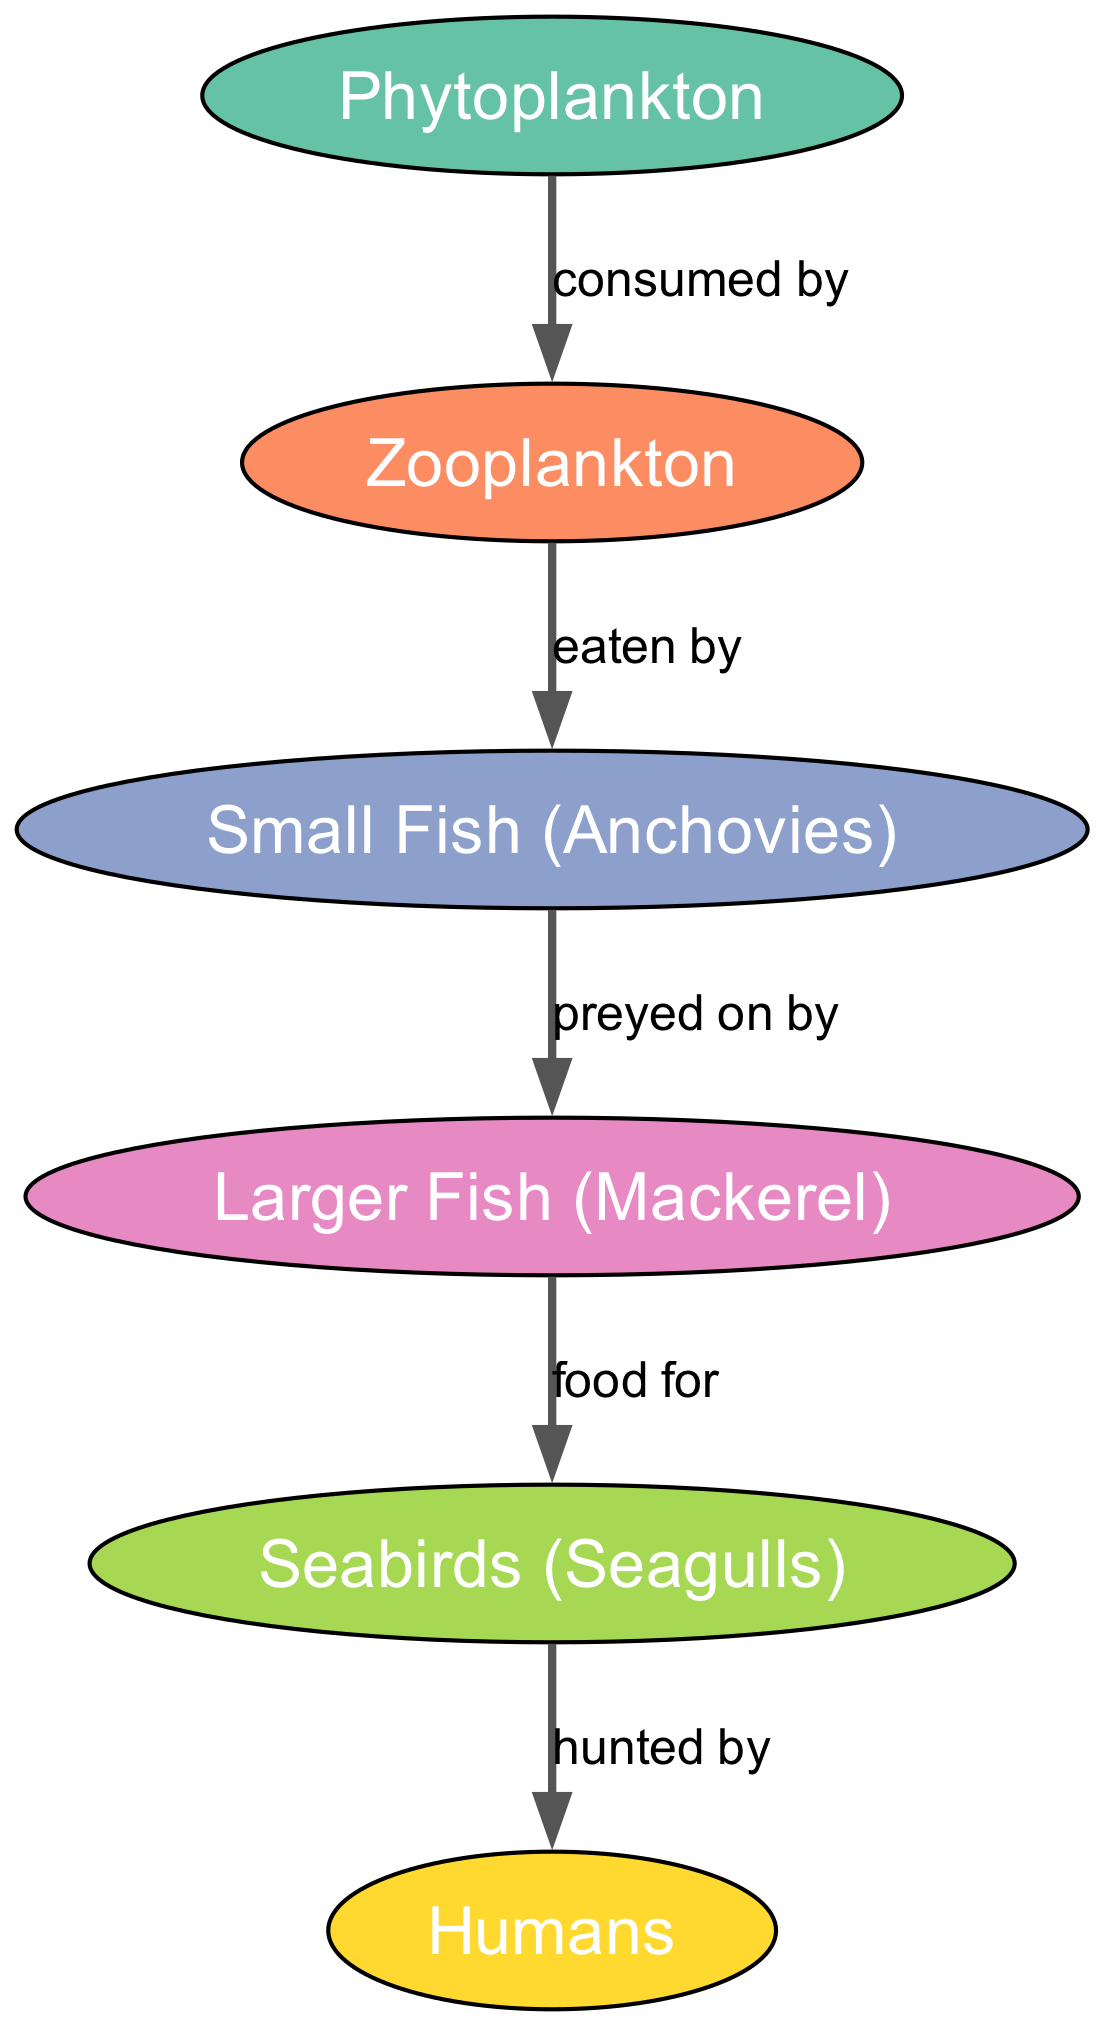What is the first node in the food chain? The first node in the food chain is Phytoplankton, as it is positioned at the top of the diagram and has edges leading to other nodes.
Answer: Phytoplankton How many edges are present in the diagram? The diagram shows a total of 5 edges connecting the nodes, indicating the relationships in the food chain.
Answer: 5 Which species is directly eaten by larger fish? According to the diagram, Small Fish (Anchovies) is the species that is directly eaten by Larger Fish (Mackerel), as indicated by the edge connecting them.
Answer: Small Fish (Anchovies) What type of relationship exists between seabirds and humans? The relationship between seabirds (Seagulls) and humans is labeled as "hunted by," which signifies that humans hunt seabirds as part of the food chain.
Answer: hunted by Which organism serves as a food source for seabirds? The diagram clearly indicates that Larger Fish (Mackerel) serves as a food source for Seabirds (Seagulls), shown by the directed edge leading from one to the other.
Answer: Larger Fish (Mackerel) How does Zooplankton relate to Phytoplankton? Zooplankton is consumed by Phytoplankton, as indicated by the directed edge from Phytoplankton to Zooplankton in the diagram, establishing a predator-prey relationship.
Answer: consumed by What is the last organism in the food chain? The last organism in the food chain is Humans, as it is positioned at the end of the flow in the diagram and has no outgoing edges.
Answer: Humans Which type of plankton is at the second level of the food chain? The second level of the food chain comprises Zooplankton, which is directly related to the first level, Phytoplankton, by being eaten by it.
Answer: Zooplankton What is the direct predecessor of Seabirds in the food chain? Seabirds have Larger Fish (Mackerel) as their direct predecessor in the food chain, connected by a directed edge indicating the flow of energy.
Answer: Larger Fish (Mackerel) 